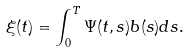<formula> <loc_0><loc_0><loc_500><loc_500>\xi ( t ) = \int _ { 0 } ^ { T } \Psi ( t , s ) b ( s ) d s .</formula> 